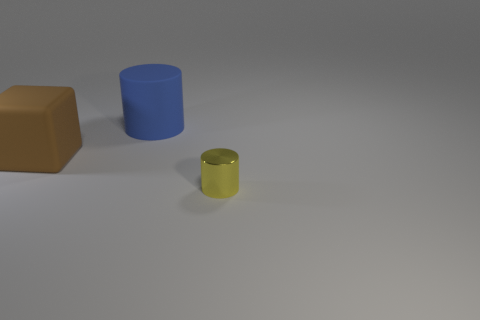Add 1 big brown matte cubes. How many objects exist? 4 Subtract all cylinders. How many objects are left? 1 Subtract all yellow cubes. Subtract all blue cylinders. How many cubes are left? 1 Subtract all big green things. Subtract all yellow cylinders. How many objects are left? 2 Add 1 large brown matte cubes. How many large brown matte cubes are left? 2 Add 2 brown rubber cubes. How many brown rubber cubes exist? 3 Subtract 0 gray spheres. How many objects are left? 3 